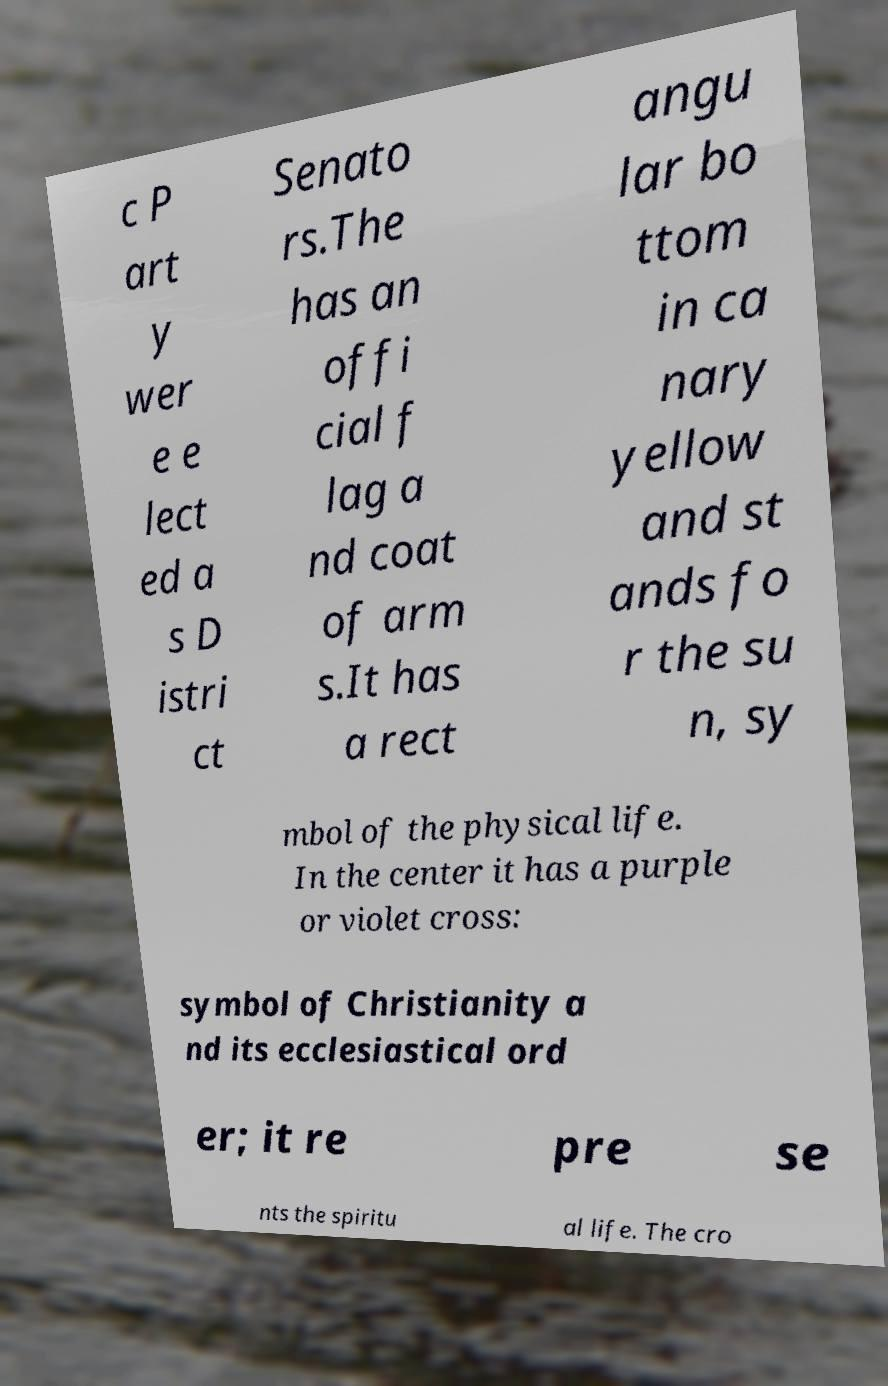Could you extract and type out the text from this image? c P art y wer e e lect ed a s D istri ct Senato rs.The has an offi cial f lag a nd coat of arm s.It has a rect angu lar bo ttom in ca nary yellow and st ands fo r the su n, sy mbol of the physical life. In the center it has a purple or violet cross: symbol of Christianity a nd its ecclesiastical ord er; it re pre se nts the spiritu al life. The cro 